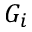Convert formula to latex. <formula><loc_0><loc_0><loc_500><loc_500>G _ { i }</formula> 